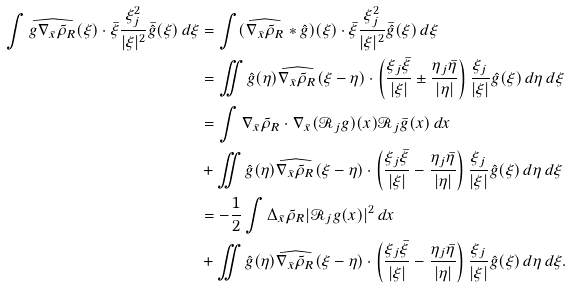Convert formula to latex. <formula><loc_0><loc_0><loc_500><loc_500>\int \widehat { g \nabla _ { \bar { x } } \tilde { \rho } _ { R } } ( \xi ) \cdot \bar { \xi } \frac { \xi _ { j } ^ { 2 } } { | \xi | ^ { 2 } } \bar { \hat { g } } ( \xi ) \, d \xi & = \int ( \widehat { \nabla _ { \bar { x } } \tilde { \rho } _ { R } } \ast \hat { g } ) ( \xi ) \cdot \bar { \xi } \frac { \xi _ { j } ^ { 2 } } { | \xi | ^ { 2 } } \bar { \hat { g } } ( \xi ) \, d \xi \\ & = \iint \hat { g } ( \eta ) \widehat { \nabla _ { \bar { x } } \tilde { \rho } _ { R } } ( \xi - \eta ) \cdot \left ( \frac { \xi _ { j } \bar { \xi } } { | \xi | } \pm \frac { \eta _ { j } \bar { \eta } } { | \eta | } \right ) \frac { \xi _ { j } } { | \xi | } \hat { g } ( \xi ) \, d \eta \, d \xi \\ & = \int \nabla _ { \bar { x } } \tilde { \rho } _ { R } \cdot \nabla _ { \bar { x } } ( \mathcal { R } _ { j } g ) ( x ) \mathcal { R } _ { j } \bar { g } ( x ) \, d x \\ & + \iint \hat { g } ( \eta ) \widehat { \nabla _ { \bar { x } } \tilde { \rho } _ { R } } ( \xi - \eta ) \cdot \left ( \frac { \xi _ { j } \bar { \xi } } { | \xi | } - \frac { \eta _ { j } \bar { \eta } } { | \eta | } \right ) \frac { \xi _ { j } } { | \xi | } \hat { g } ( \xi ) \, d \eta \, d \xi \\ & = - \frac { 1 } { 2 } \int \Delta _ { \bar { x } } \tilde { \rho } _ { R } | \mathcal { R } _ { j } g ( x ) | ^ { 2 } \, d x \\ & + \iint \hat { g } ( \eta ) \widehat { \nabla _ { \bar { x } } \tilde { \rho } _ { R } } ( \xi - \eta ) \cdot \left ( \frac { \xi _ { j } \bar { \xi } } { | \xi | } - \frac { \eta _ { j } \bar { \eta } } { | \eta | } \right ) \frac { \xi _ { j } } { | \xi | } \hat { g } ( \xi ) \, d \eta \, d \xi .</formula> 